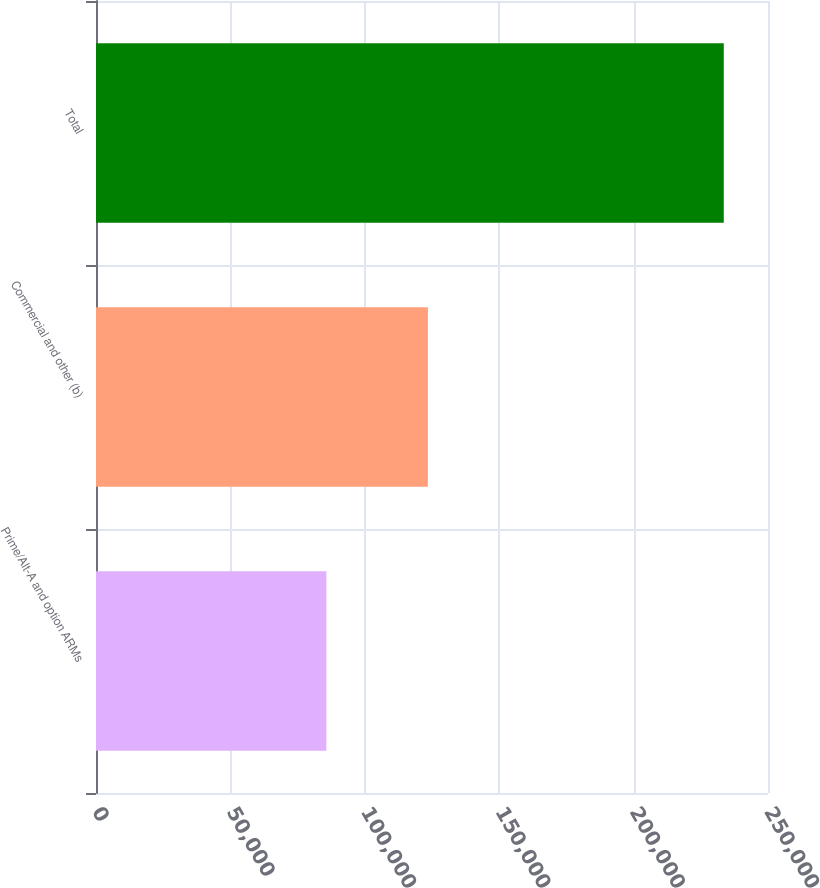Convert chart. <chart><loc_0><loc_0><loc_500><loc_500><bar_chart><fcel>Prime/Alt-A and option ARMs<fcel>Commercial and other (b)<fcel>Total<nl><fcel>85687<fcel>123474<fcel>233550<nl></chart> 